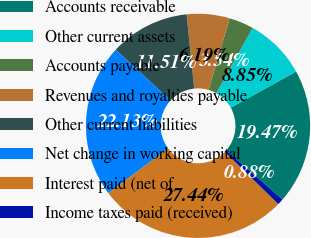Convert chart to OTSL. <chart><loc_0><loc_0><loc_500><loc_500><pie_chart><fcel>Accounts receivable<fcel>Other current assets<fcel>Accounts payable<fcel>Revenues and royalties payable<fcel>Other current liabilities<fcel>Net change in working capital<fcel>Interest paid (net of<fcel>Income taxes paid (received)<nl><fcel>19.47%<fcel>8.85%<fcel>3.54%<fcel>6.19%<fcel>11.51%<fcel>22.13%<fcel>27.45%<fcel>0.88%<nl></chart> 